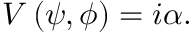Convert formula to latex. <formula><loc_0><loc_0><loc_500><loc_500>V \left ( \psi , \phi \right ) = i \alpha .</formula> 